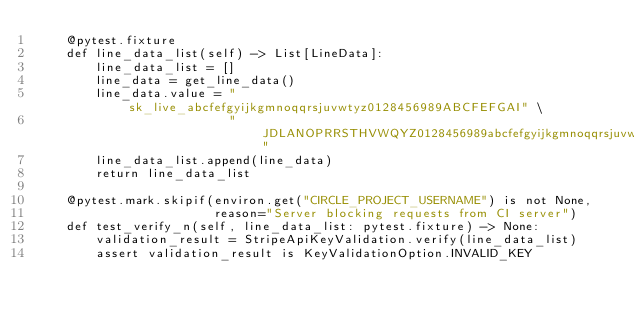<code> <loc_0><loc_0><loc_500><loc_500><_Python_>    @pytest.fixture
    def line_data_list(self) -> List[LineData]:
        line_data_list = []
        line_data = get_line_data()
        line_data.value = "sk_live_abcfefgyijkgmnoqqrsjuvwtyz0128456989ABCFEFGAI" \
                          "JDLANOPRRSTHVWQYZ0128456989abcfefgyijkgmnoqqrsjuvwtyz0"
        line_data_list.append(line_data)
        return line_data_list

    @pytest.mark.skipif(environ.get("CIRCLE_PROJECT_USERNAME") is not None,
                        reason="Server blocking requests from CI server")
    def test_verify_n(self, line_data_list: pytest.fixture) -> None:
        validation_result = StripeApiKeyValidation.verify(line_data_list)
        assert validation_result is KeyValidationOption.INVALID_KEY
</code> 